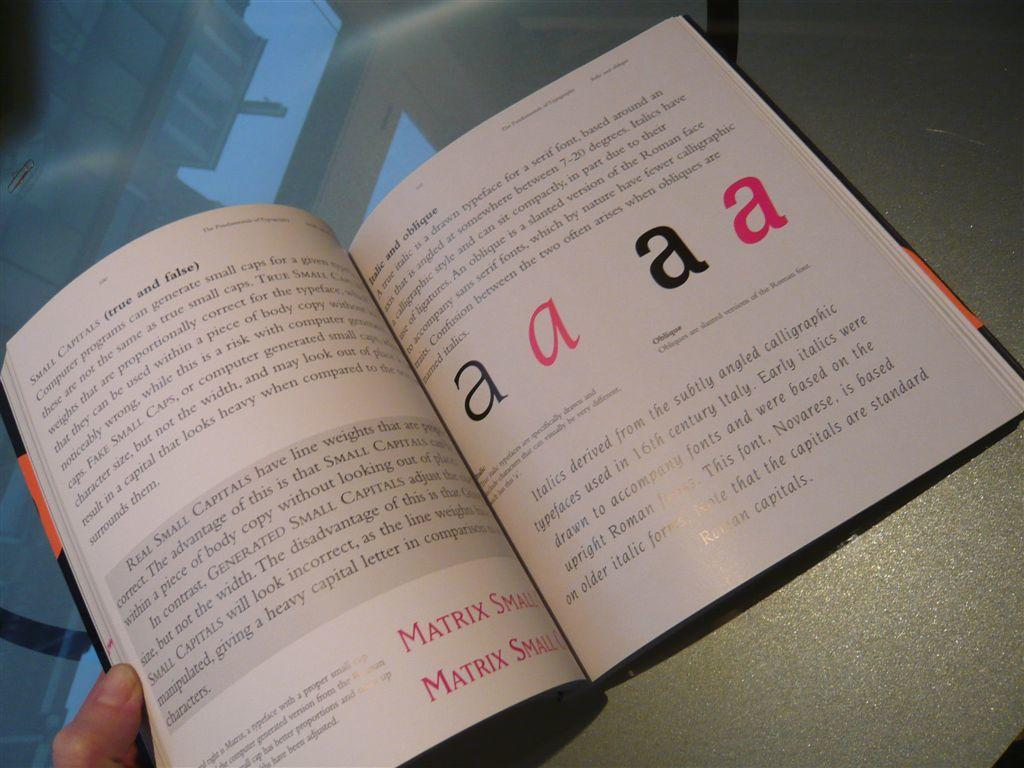<image>
Summarize the visual content of the image. An open book is open to a page with the letter A written on it  four times. 